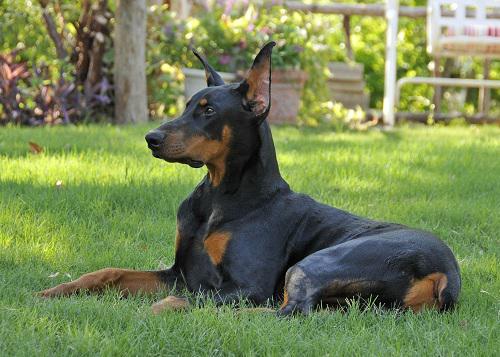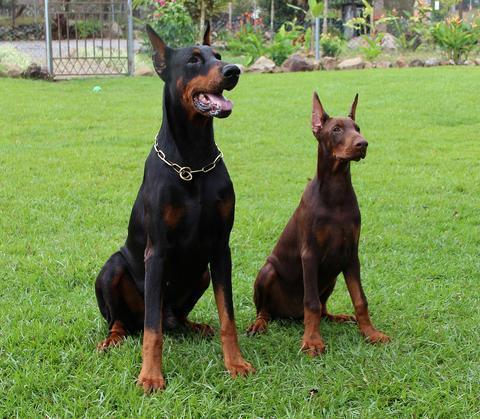The first image is the image on the left, the second image is the image on the right. Assess this claim about the two images: "One image contains one pointy-eared doberman in a reclining pose with upright head, and the other image features side-by-side pointy-eared dobermans - one brown and one black-and-tan.". Correct or not? Answer yes or no. Yes. The first image is the image on the left, the second image is the image on the right. Examine the images to the left and right. Is the description "One image shows a single dog lying on grass with its front paws extended and crossed." accurate? Answer yes or no. No. 